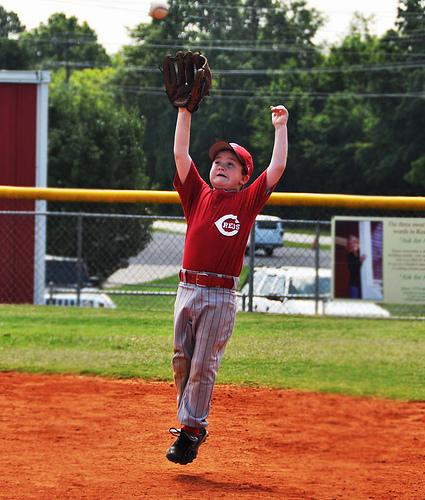What is the outcome if the ball went over the fence? Please explain your reasoning. home run. The outcome is a home run. 